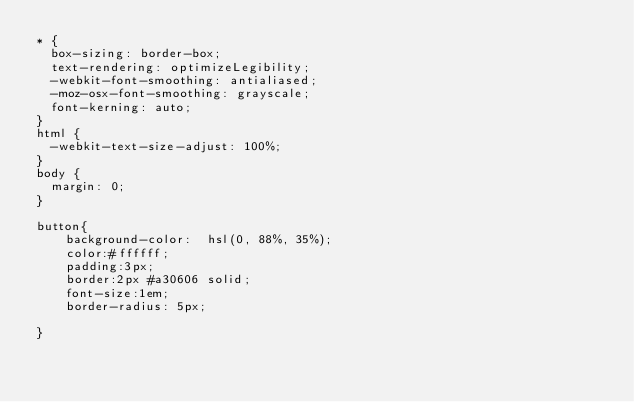Convert code to text. <code><loc_0><loc_0><loc_500><loc_500><_CSS_>* {
  box-sizing: border-box;
  text-rendering: optimizeLegibility;
  -webkit-font-smoothing: antialiased;
  -moz-osx-font-smoothing: grayscale;
  font-kerning: auto;
}
html {
  -webkit-text-size-adjust: 100%;
}
body {
  margin: 0;
}

button{
    background-color:  hsl(0, 88%, 35%);
    color:#ffffff;
    padding:3px;
    border:2px #a30606 solid;
    font-size:1em;
    border-radius: 5px;

}
</code> 